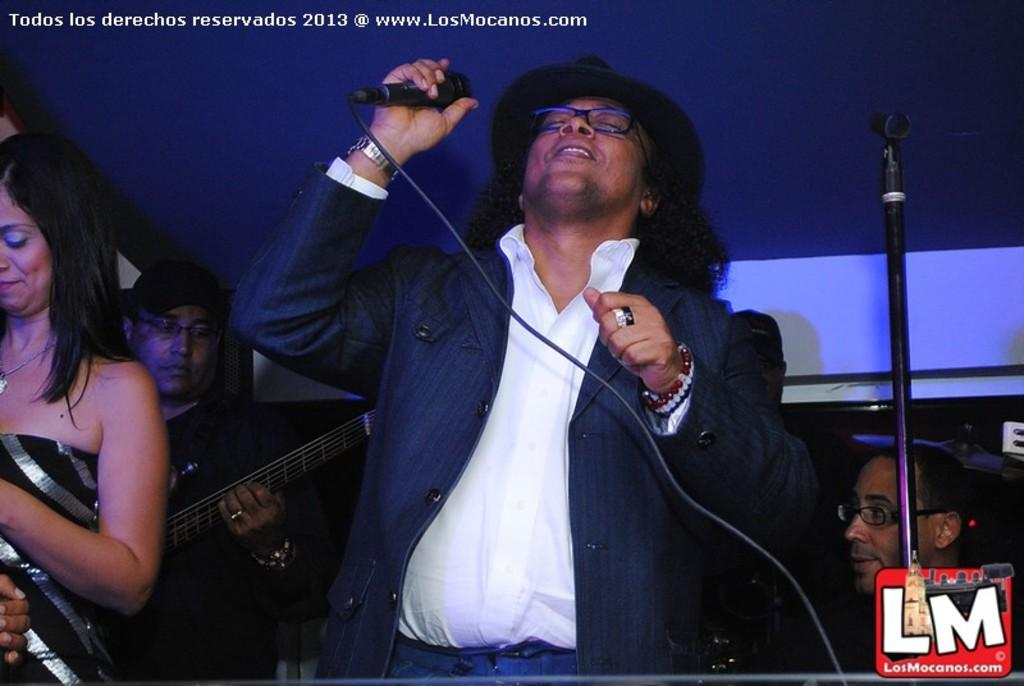Who is the main subject in the image? There is a man in the image. What is the man holding in his hand? The man is holding a microphone in his hand. Can you describe the man's appearance? The man is wearing spectacles. Are there any other people visible in the image? Yes, there are other persons visible in the image. What rule is the man enforcing with his seat in the image? There is no mention of a seat or rule in the image; the man is holding a microphone. 